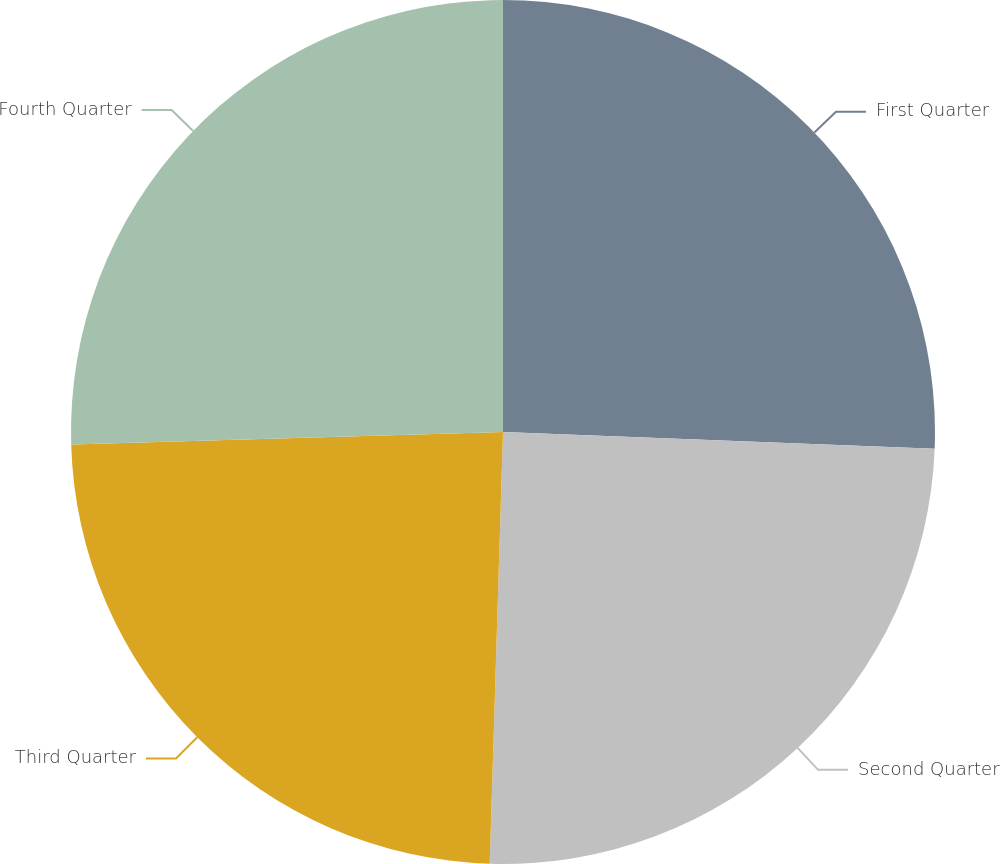Convert chart. <chart><loc_0><loc_0><loc_500><loc_500><pie_chart><fcel>First Quarter<fcel>Second Quarter<fcel>Third Quarter<fcel>Fourth Quarter<nl><fcel>25.62%<fcel>24.87%<fcel>24.05%<fcel>25.46%<nl></chart> 